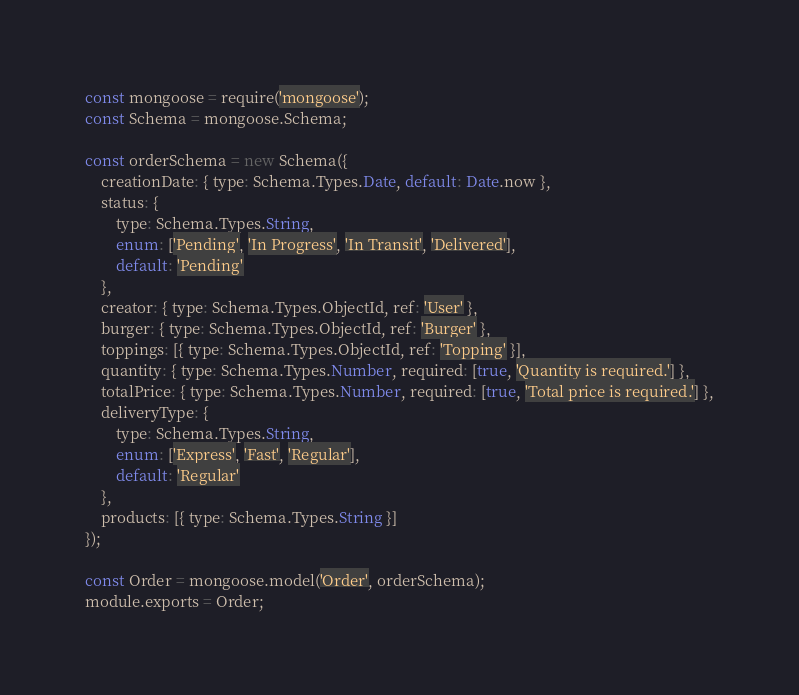<code> <loc_0><loc_0><loc_500><loc_500><_JavaScript_>const mongoose = require('mongoose');
const Schema = mongoose.Schema;

const orderSchema = new Schema({
    creationDate: { type: Schema.Types.Date, default: Date.now },
    status: { 
        type: Schema.Types.String, 
        enum: ['Pending', 'In Progress', 'In Transit', 'Delivered'],
        default: 'Pending'
    },
    creator: { type: Schema.Types.ObjectId, ref: 'User' },
    burger: { type: Schema.Types.ObjectId, ref: 'Burger' },
    toppings: [{ type: Schema.Types.ObjectId, ref: 'Topping' }],
    quantity: { type: Schema.Types.Number, required: [true, 'Quantity is required.'] },
    totalPrice: { type: Schema.Types.Number, required: [true, 'Total price is required.'] },
    deliveryType: { 
        type: Schema.Types.String, 
        enum: ['Express', 'Fast', 'Regular'],
        default: 'Regular'
    },
    products: [{ type: Schema.Types.String }]
});

const Order = mongoose.model('Order', orderSchema);
module.exports = Order;
</code> 